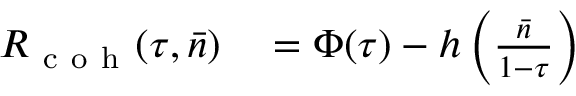<formula> <loc_0><loc_0><loc_500><loc_500>\begin{array} { r l } { R _ { c o h } ( \tau , \bar { n } ) } & = \Phi ( \tau ) - h \left ( \frac { \bar { n } } { 1 - \tau } \right ) } \end{array}</formula> 